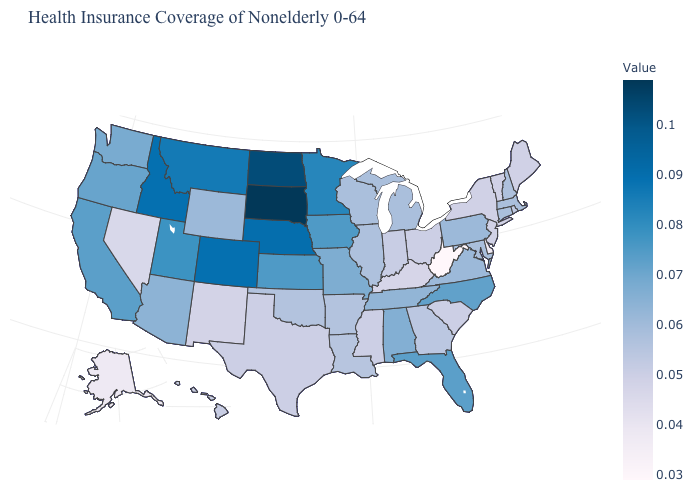Among the states that border Ohio , does West Virginia have the lowest value?
Quick response, please. Yes. Does Louisiana have a higher value than Colorado?
Keep it brief. No. Does West Virginia have the lowest value in the South?
Answer briefly. Yes. Does Utah have a lower value than Wisconsin?
Quick response, please. No. 